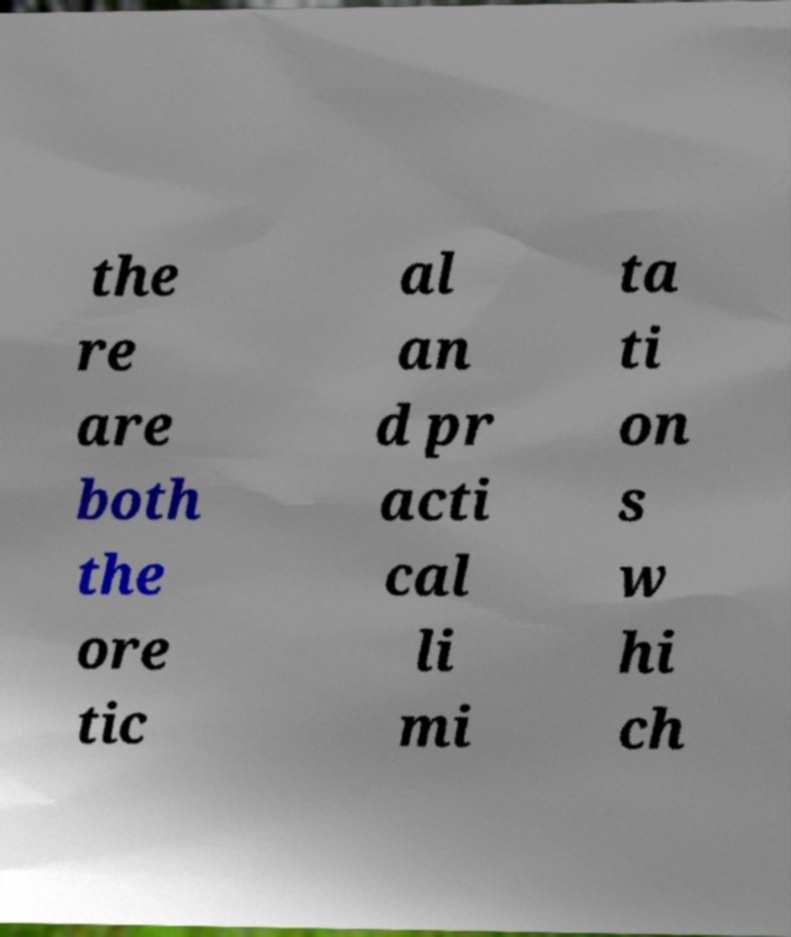Please identify and transcribe the text found in this image. the re are both the ore tic al an d pr acti cal li mi ta ti on s w hi ch 